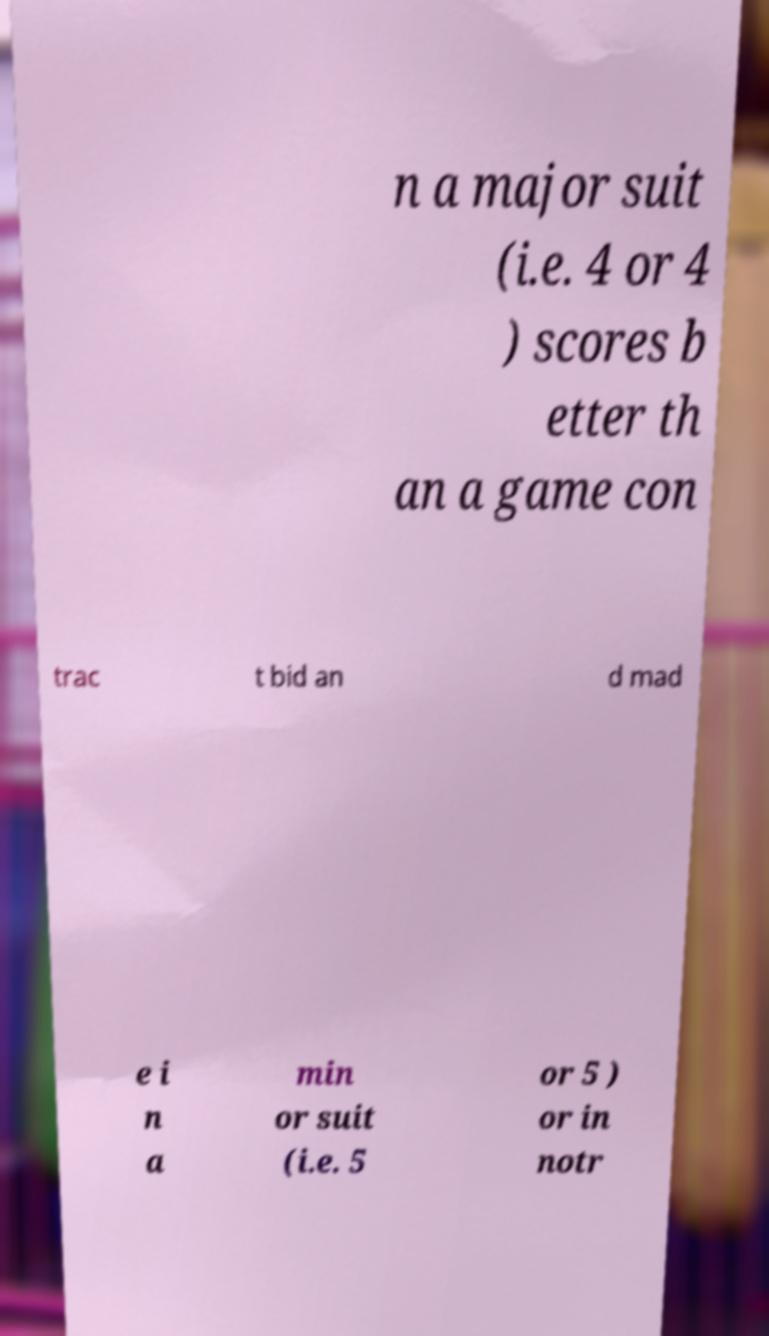For documentation purposes, I need the text within this image transcribed. Could you provide that? n a major suit (i.e. 4 or 4 ) scores b etter th an a game con trac t bid an d mad e i n a min or suit (i.e. 5 or 5 ) or in notr 